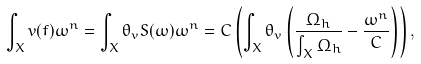<formula> <loc_0><loc_0><loc_500><loc_500>\int _ { X } v ( f ) \omega ^ { n } = \int _ { X } \theta _ { v } S ( \omega ) \omega ^ { n } = C \left ( \int _ { X } \theta _ { v } \left ( \frac { \Omega _ { h } } { \int _ { X } \Omega _ { h } } - \frac { \omega ^ { n } } { C } \right ) \right ) ,</formula> 